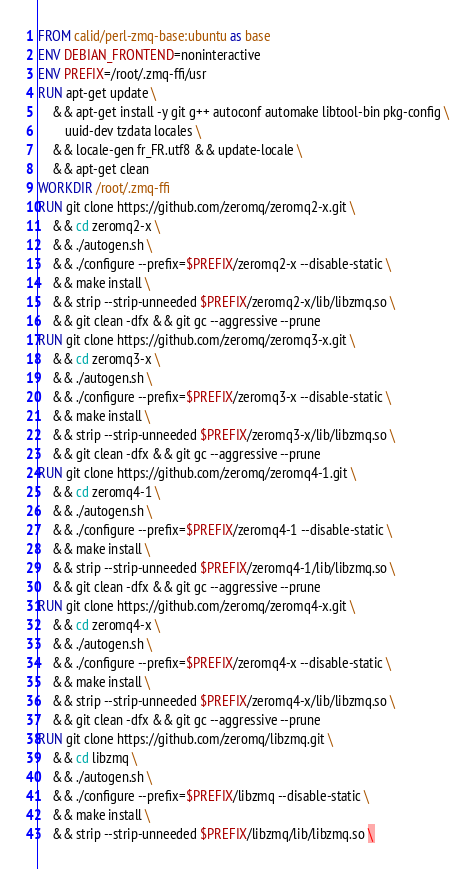Convert code to text. <code><loc_0><loc_0><loc_500><loc_500><_Dockerfile_>FROM calid/perl-zmq-base:ubuntu as base
ENV DEBIAN_FRONTEND=noninteractive
ENV PREFIX=/root/.zmq-ffi/usr
RUN apt-get update \
    && apt-get install -y git g++ autoconf automake libtool-bin pkg-config \
        uuid-dev tzdata locales \
    && locale-gen fr_FR.utf8 && update-locale \
    && apt-get clean
WORKDIR /root/.zmq-ffi
RUN git clone https://github.com/zeromq/zeromq2-x.git \
    && cd zeromq2-x \
    && ./autogen.sh \
    && ./configure --prefix=$PREFIX/zeromq2-x --disable-static \
    && make install \
    && strip --strip-unneeded $PREFIX/zeromq2-x/lib/libzmq.so \
    && git clean -dfx && git gc --aggressive --prune
RUN git clone https://github.com/zeromq/zeromq3-x.git \
    && cd zeromq3-x \
    && ./autogen.sh \
    && ./configure --prefix=$PREFIX/zeromq3-x --disable-static \
    && make install \
    && strip --strip-unneeded $PREFIX/zeromq3-x/lib/libzmq.so \
    && git clean -dfx && git gc --aggressive --prune
RUN git clone https://github.com/zeromq/zeromq4-1.git \
    && cd zeromq4-1 \
    && ./autogen.sh \
    && ./configure --prefix=$PREFIX/zeromq4-1 --disable-static \
    && make install \
    && strip --strip-unneeded $PREFIX/zeromq4-1/lib/libzmq.so \
    && git clean -dfx && git gc --aggressive --prune
RUN git clone https://github.com/zeromq/zeromq4-x.git \
    && cd zeromq4-x \
    && ./autogen.sh \
    && ./configure --prefix=$PREFIX/zeromq4-x --disable-static \
    && make install \
    && strip --strip-unneeded $PREFIX/zeromq4-x/lib/libzmq.so \
    && git clean -dfx && git gc --aggressive --prune
RUN git clone https://github.com/zeromq/libzmq.git \
    && cd libzmq \
    && ./autogen.sh \
    && ./configure --prefix=$PREFIX/libzmq --disable-static \
    && make install \
    && strip --strip-unneeded $PREFIX/libzmq/lib/libzmq.so \</code> 